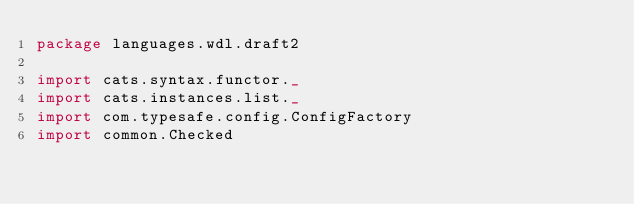Convert code to text. <code><loc_0><loc_0><loc_500><loc_500><_Scala_>package languages.wdl.draft2

import cats.syntax.functor._
import cats.instances.list._
import com.typesafe.config.ConfigFactory
import common.Checked</code> 